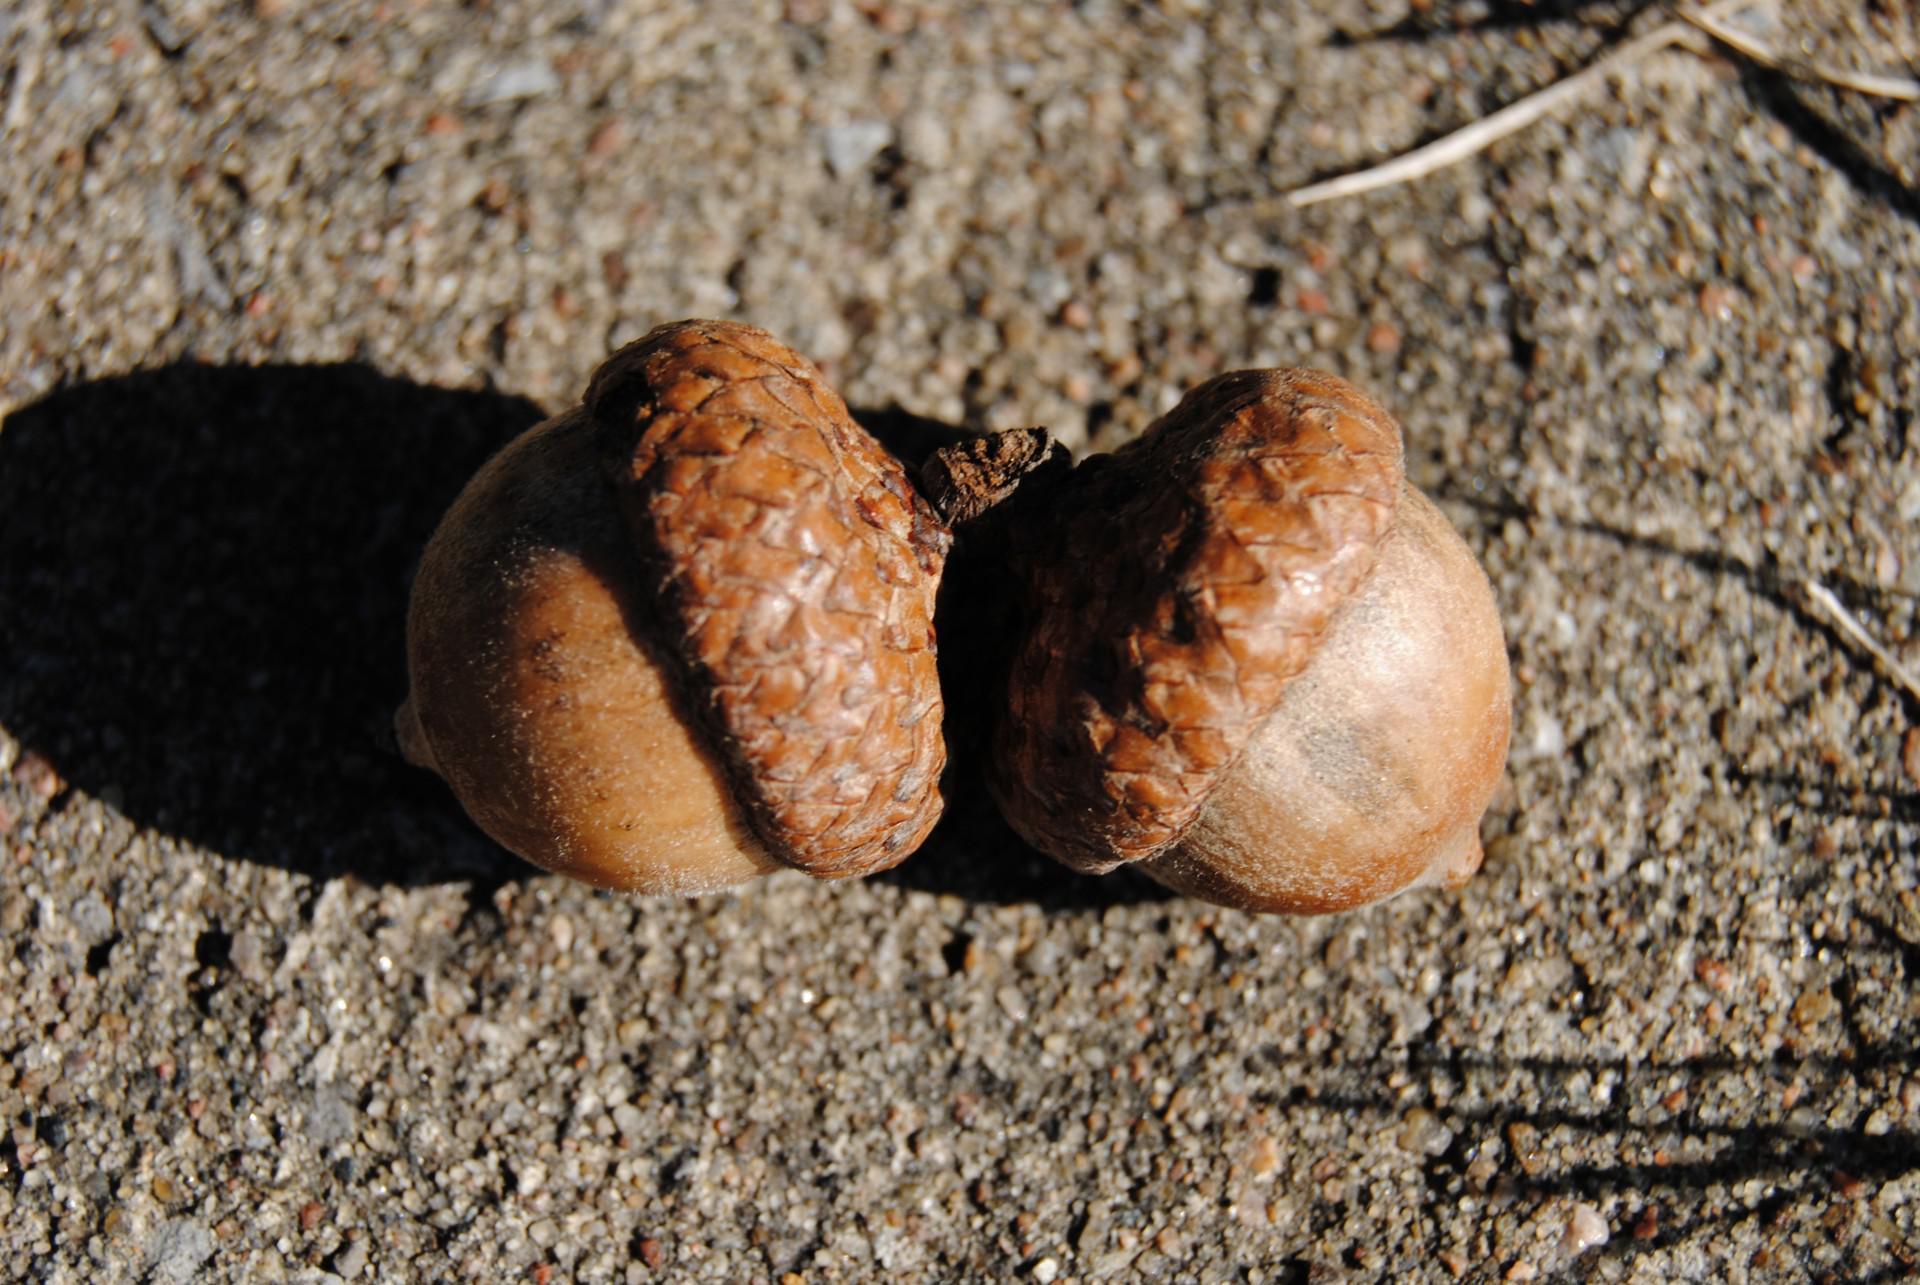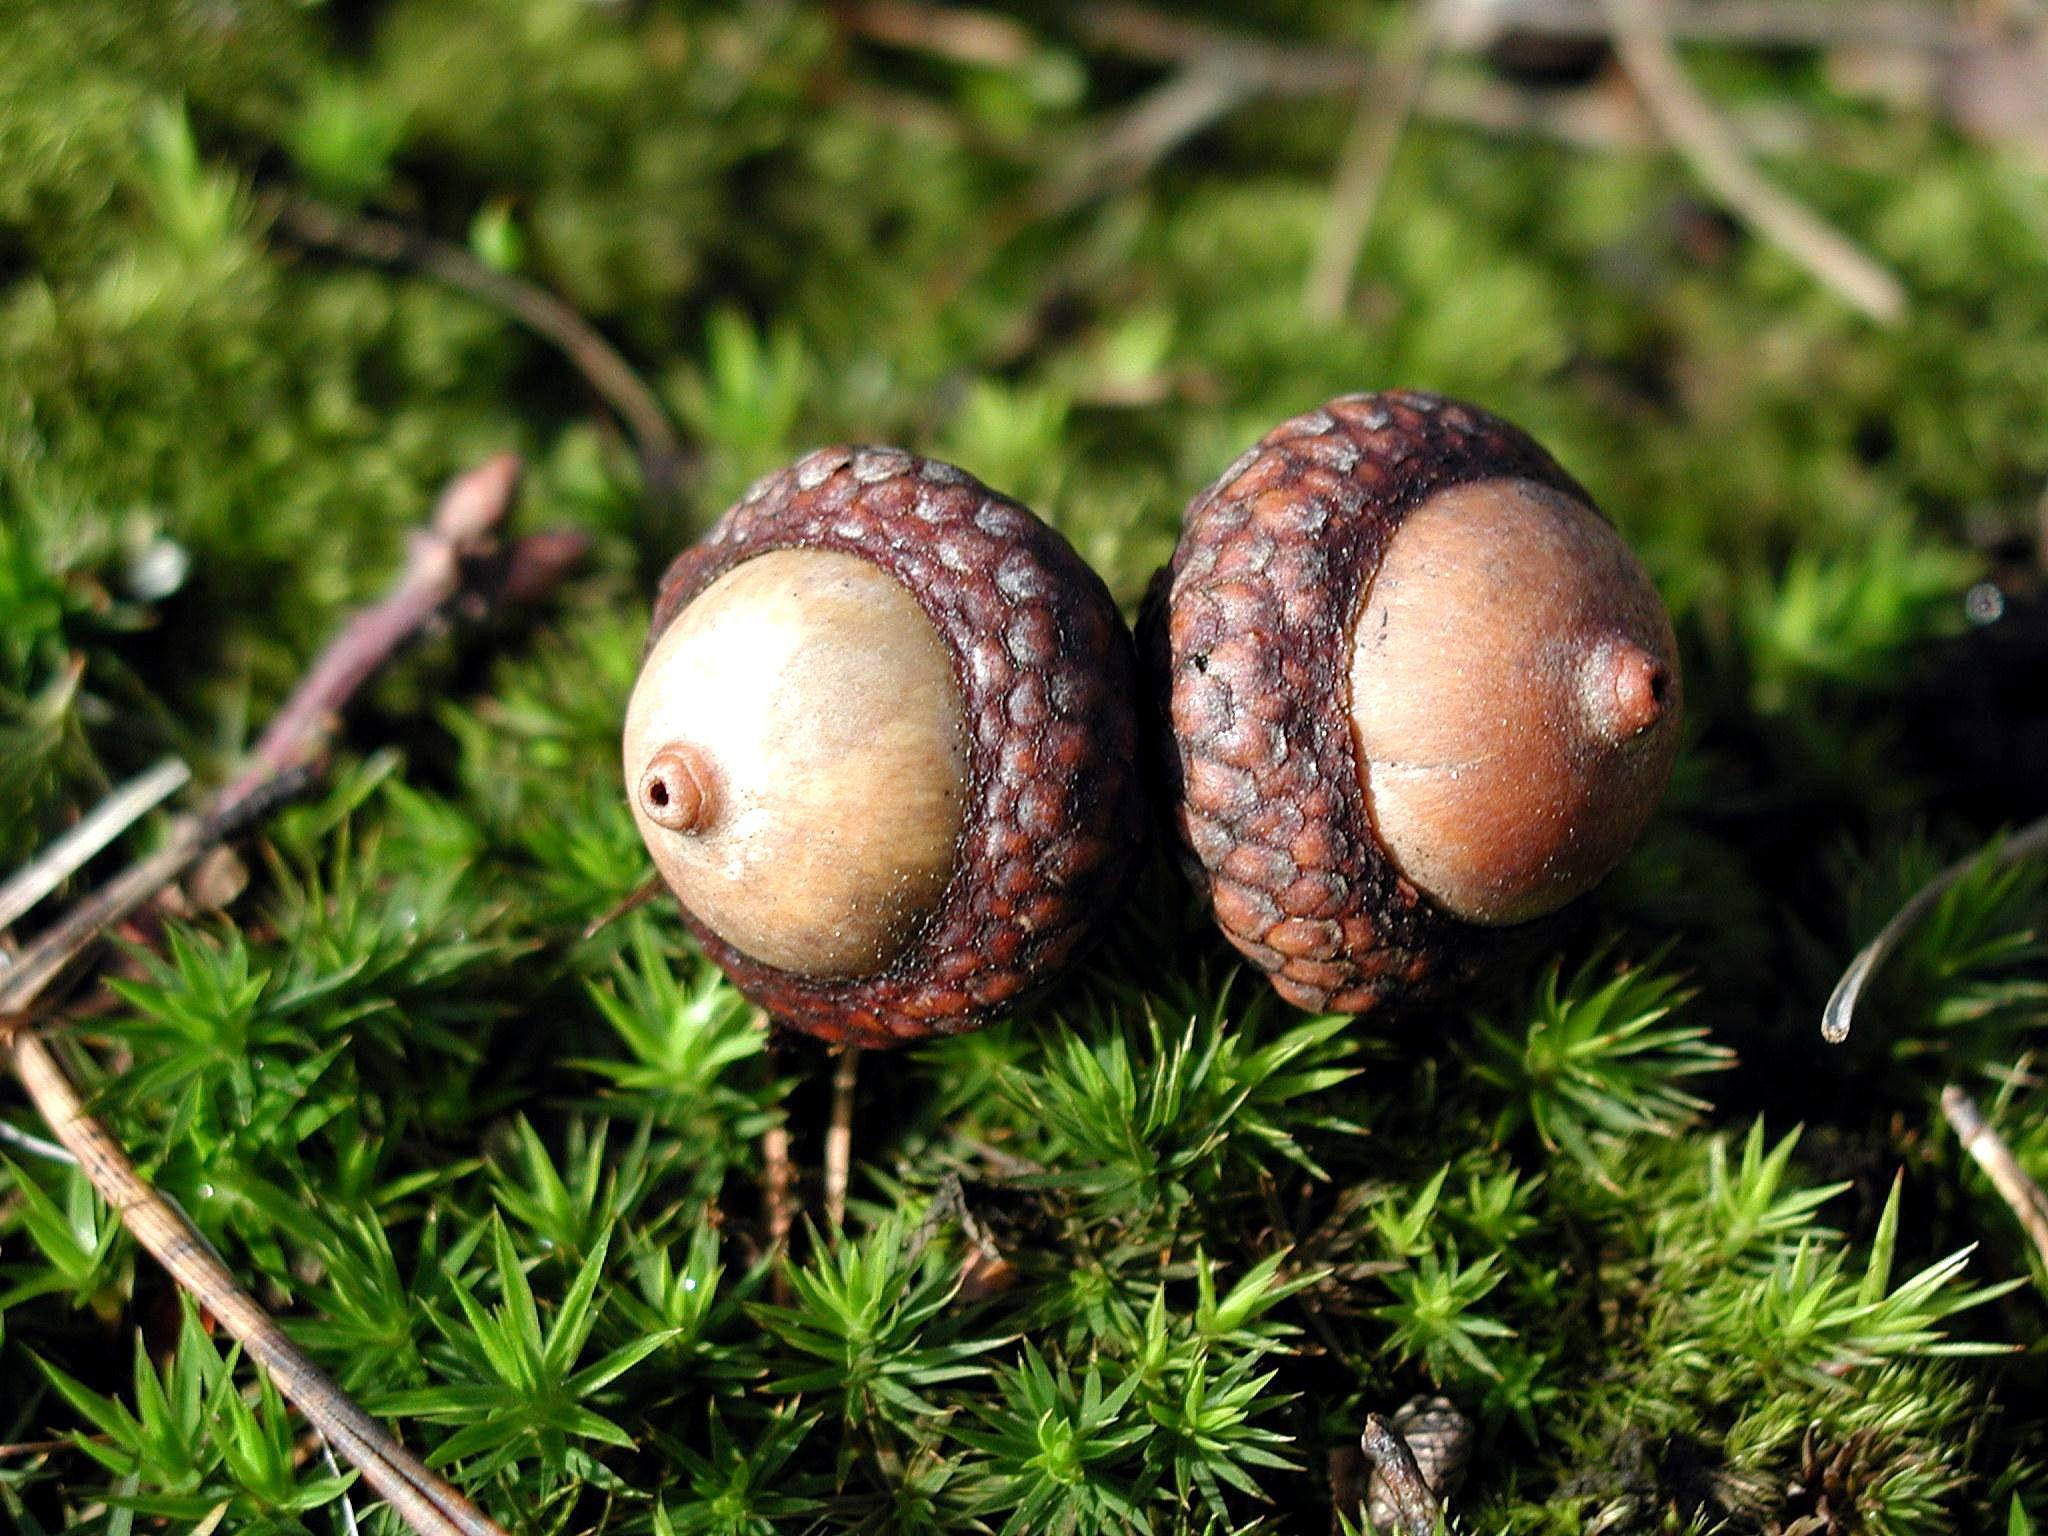The first image is the image on the left, the second image is the image on the right. Assess this claim about the two images: "in at least one image there are two of acorns attached together.". Correct or not? Answer yes or no. Yes. The first image is the image on the left, the second image is the image on the right. For the images displayed, is the sentence "One image shows exactly two brown acorns in back-to-back caps on green foliage." factually correct? Answer yes or no. Yes. 